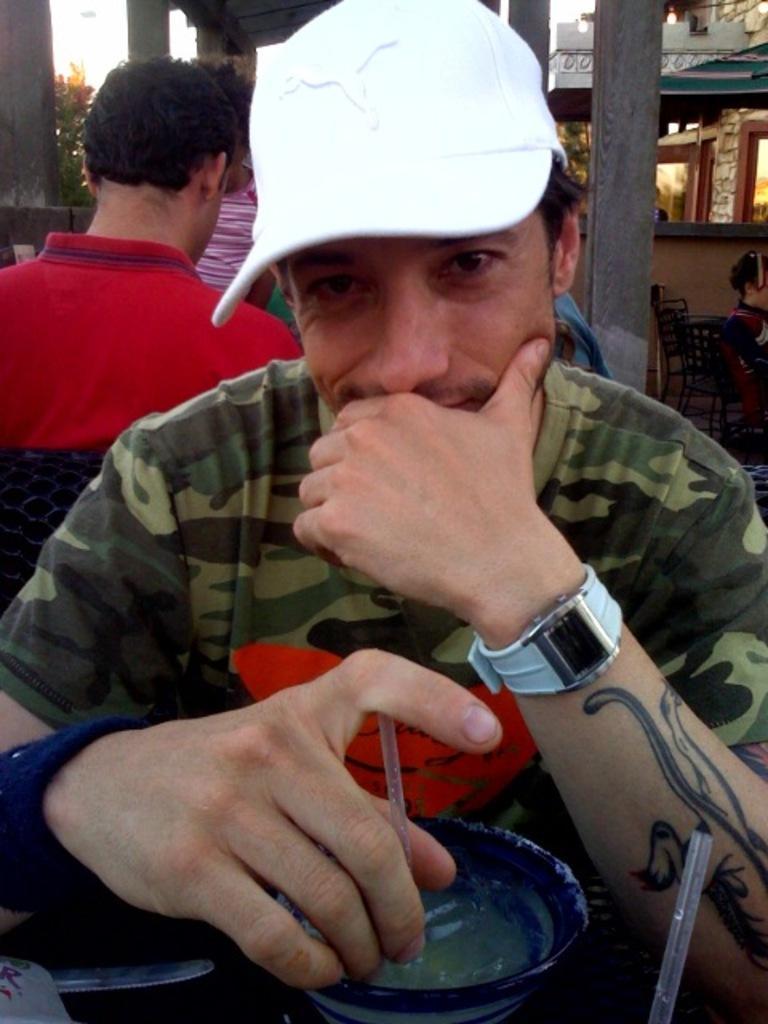Please provide a concise description of this image. In this image there is one person sitting at bottom of this image is holding a straw and there are some persons behind to this person. There are some chairs at right side of this image. 